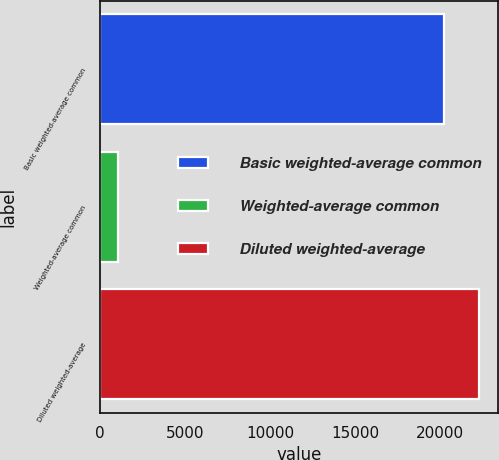Convert chart to OTSL. <chart><loc_0><loc_0><loc_500><loc_500><bar_chart><fcel>Basic weighted-average common<fcel>Weighted-average common<fcel>Diluted weighted-average<nl><fcel>20258<fcel>1038<fcel>22283.8<nl></chart> 